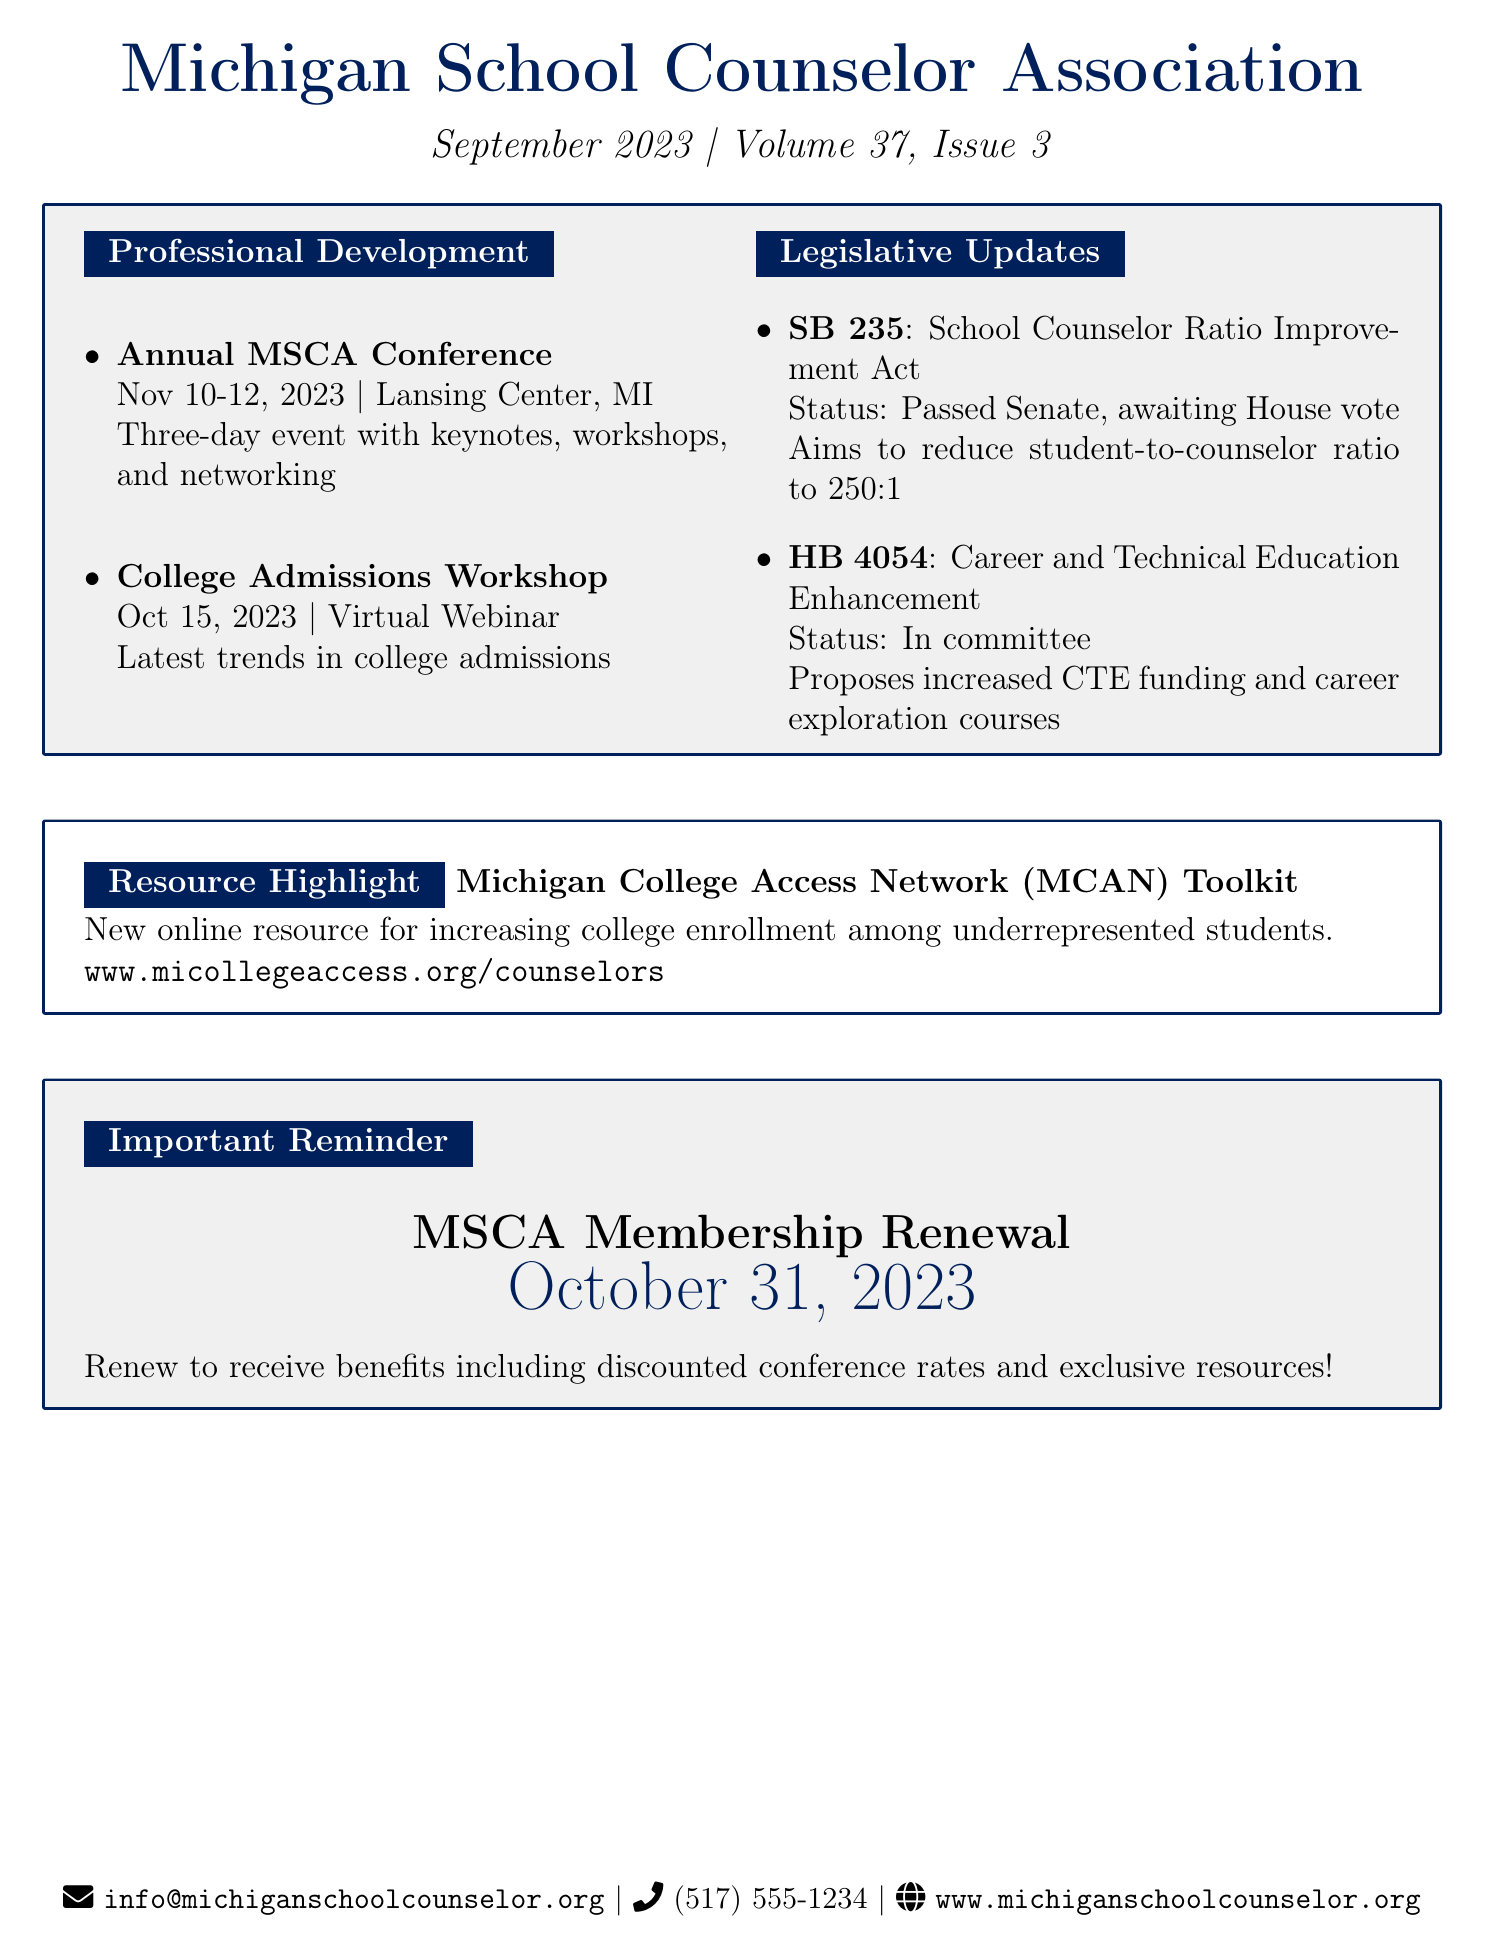What is the title of the newsletter? The title is provided in the header of the document.
Answer: Michigan School Counselor Association Newsletter When is the Annual MSCA Conference? The date for the conference is mentioned under the professional development section.
Answer: November 10-12, 2023 Where is the College Admissions Workshop being held? The location is specified in the event description for the workshop.
Answer: Virtual Webinar What is the status of bill SB 235? The status is detailed in the legislative updates section.
Answer: Passed Senate, awaiting House vote What does the Michigan College Access Network (MCAN) Toolkit aim to provide? The resource highlights its purpose as indicated in the resource section.
Answer: Tools and strategies to increase college enrollment rates among underrepresented students What is the upcoming deadline mentioned in the document? The deadline is specifically stated in the important reminder section.
Answer: October 31, 2023 What is the student-to-counselor ratio targeted by the School Counselor Ratio Improvement Act? The target ratio is outlined in the description of bill SB 235.
Answer: 250:1 What should members do by the deadline to continue receiving benefits? The action members are required to take is indicated in the important reminder.
Answer: Renew your membership 